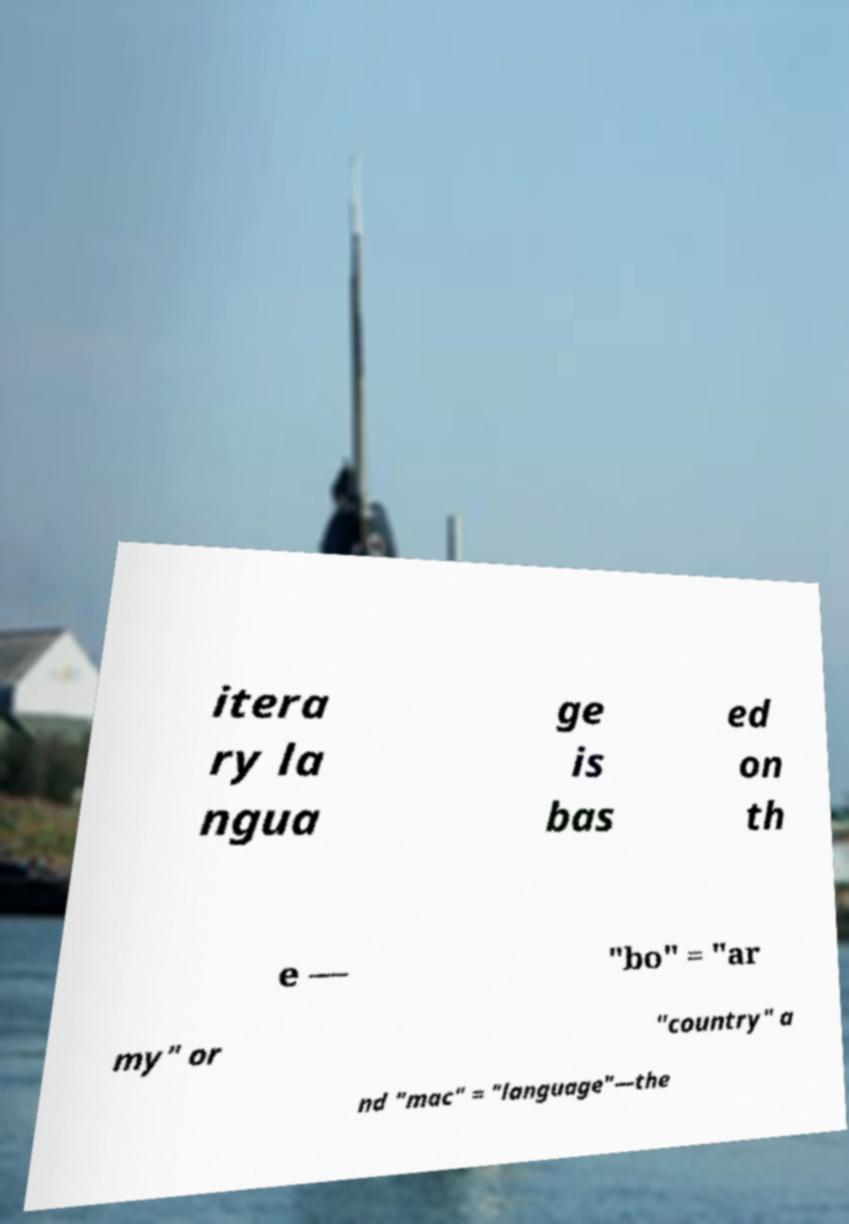I need the written content from this picture converted into text. Can you do that? itera ry la ngua ge is bas ed on th e — "bo" = "ar my" or "country" a nd "mac" = "language"—the 